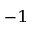Convert formula to latex. <formula><loc_0><loc_0><loc_500><loc_500>^ { - 1 }</formula> 